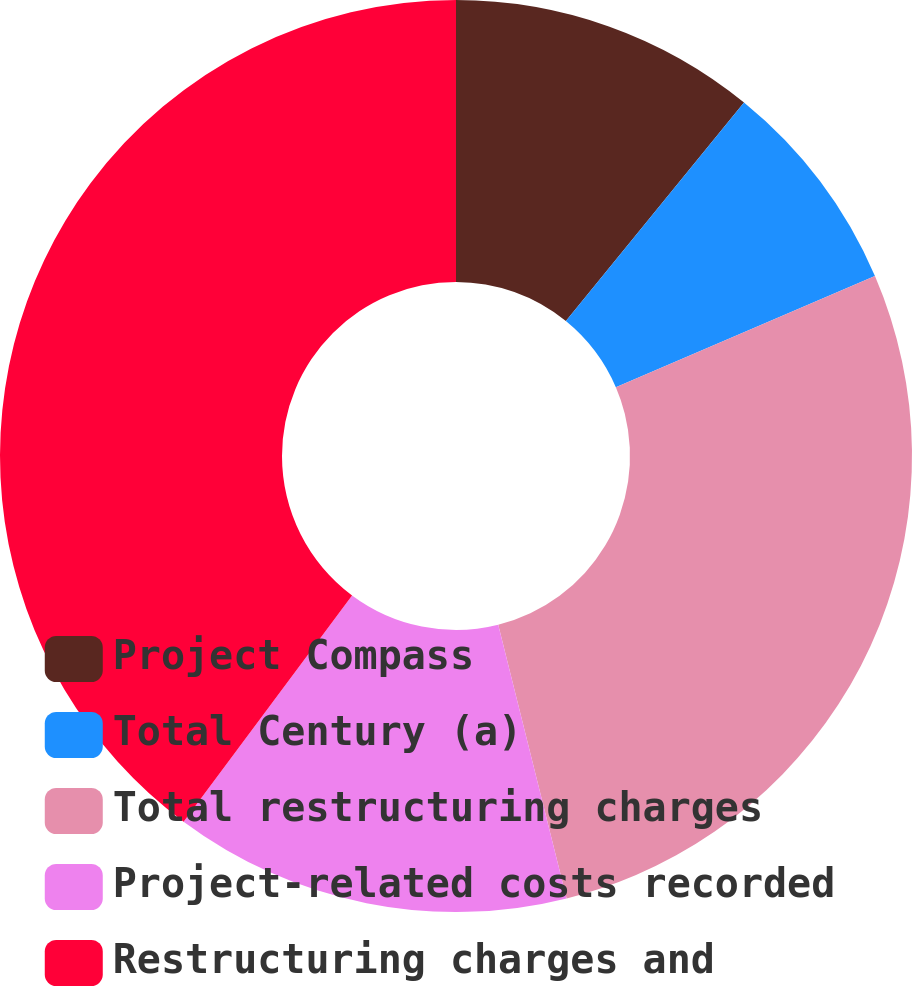<chart> <loc_0><loc_0><loc_500><loc_500><pie_chart><fcel>Project Compass<fcel>Total Century (a)<fcel>Total restructuring charges<fcel>Project-related costs recorded<fcel>Restructuring charges and<nl><fcel>10.88%<fcel>7.66%<fcel>27.56%<fcel>14.09%<fcel>39.81%<nl></chart> 